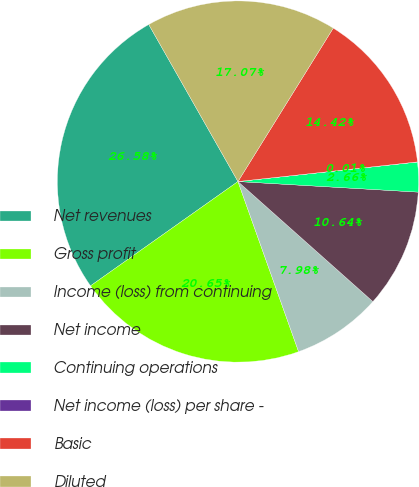<chart> <loc_0><loc_0><loc_500><loc_500><pie_chart><fcel>Net revenues<fcel>Gross profit<fcel>Income (loss) from continuing<fcel>Net income<fcel>Continuing operations<fcel>Net income (loss) per share -<fcel>Basic<fcel>Diluted<nl><fcel>26.58%<fcel>20.65%<fcel>7.98%<fcel>10.64%<fcel>2.66%<fcel>0.01%<fcel>14.42%<fcel>17.07%<nl></chart> 